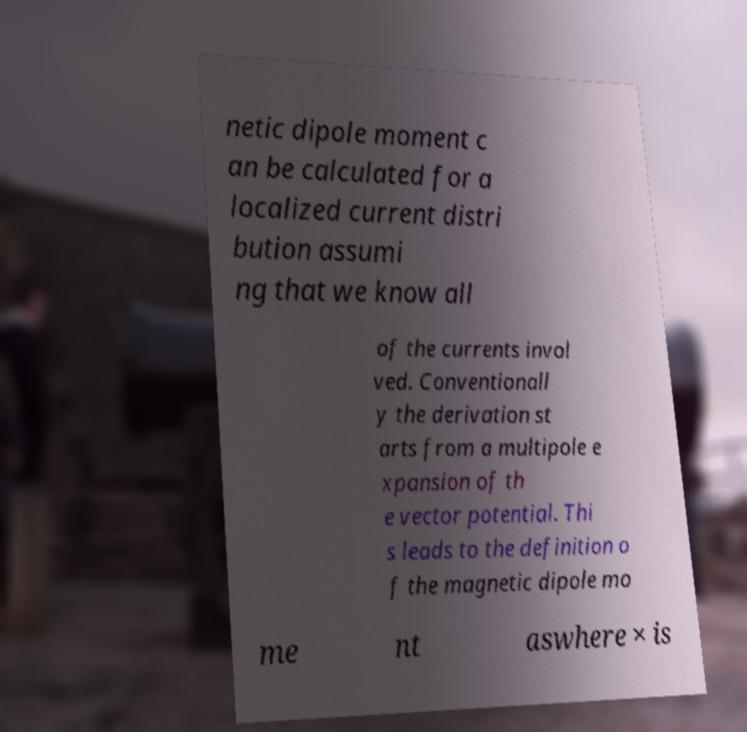Could you assist in decoding the text presented in this image and type it out clearly? netic dipole moment c an be calculated for a localized current distri bution assumi ng that we know all of the currents invol ved. Conventionall y the derivation st arts from a multipole e xpansion of th e vector potential. Thi s leads to the definition o f the magnetic dipole mo me nt aswhere × is 